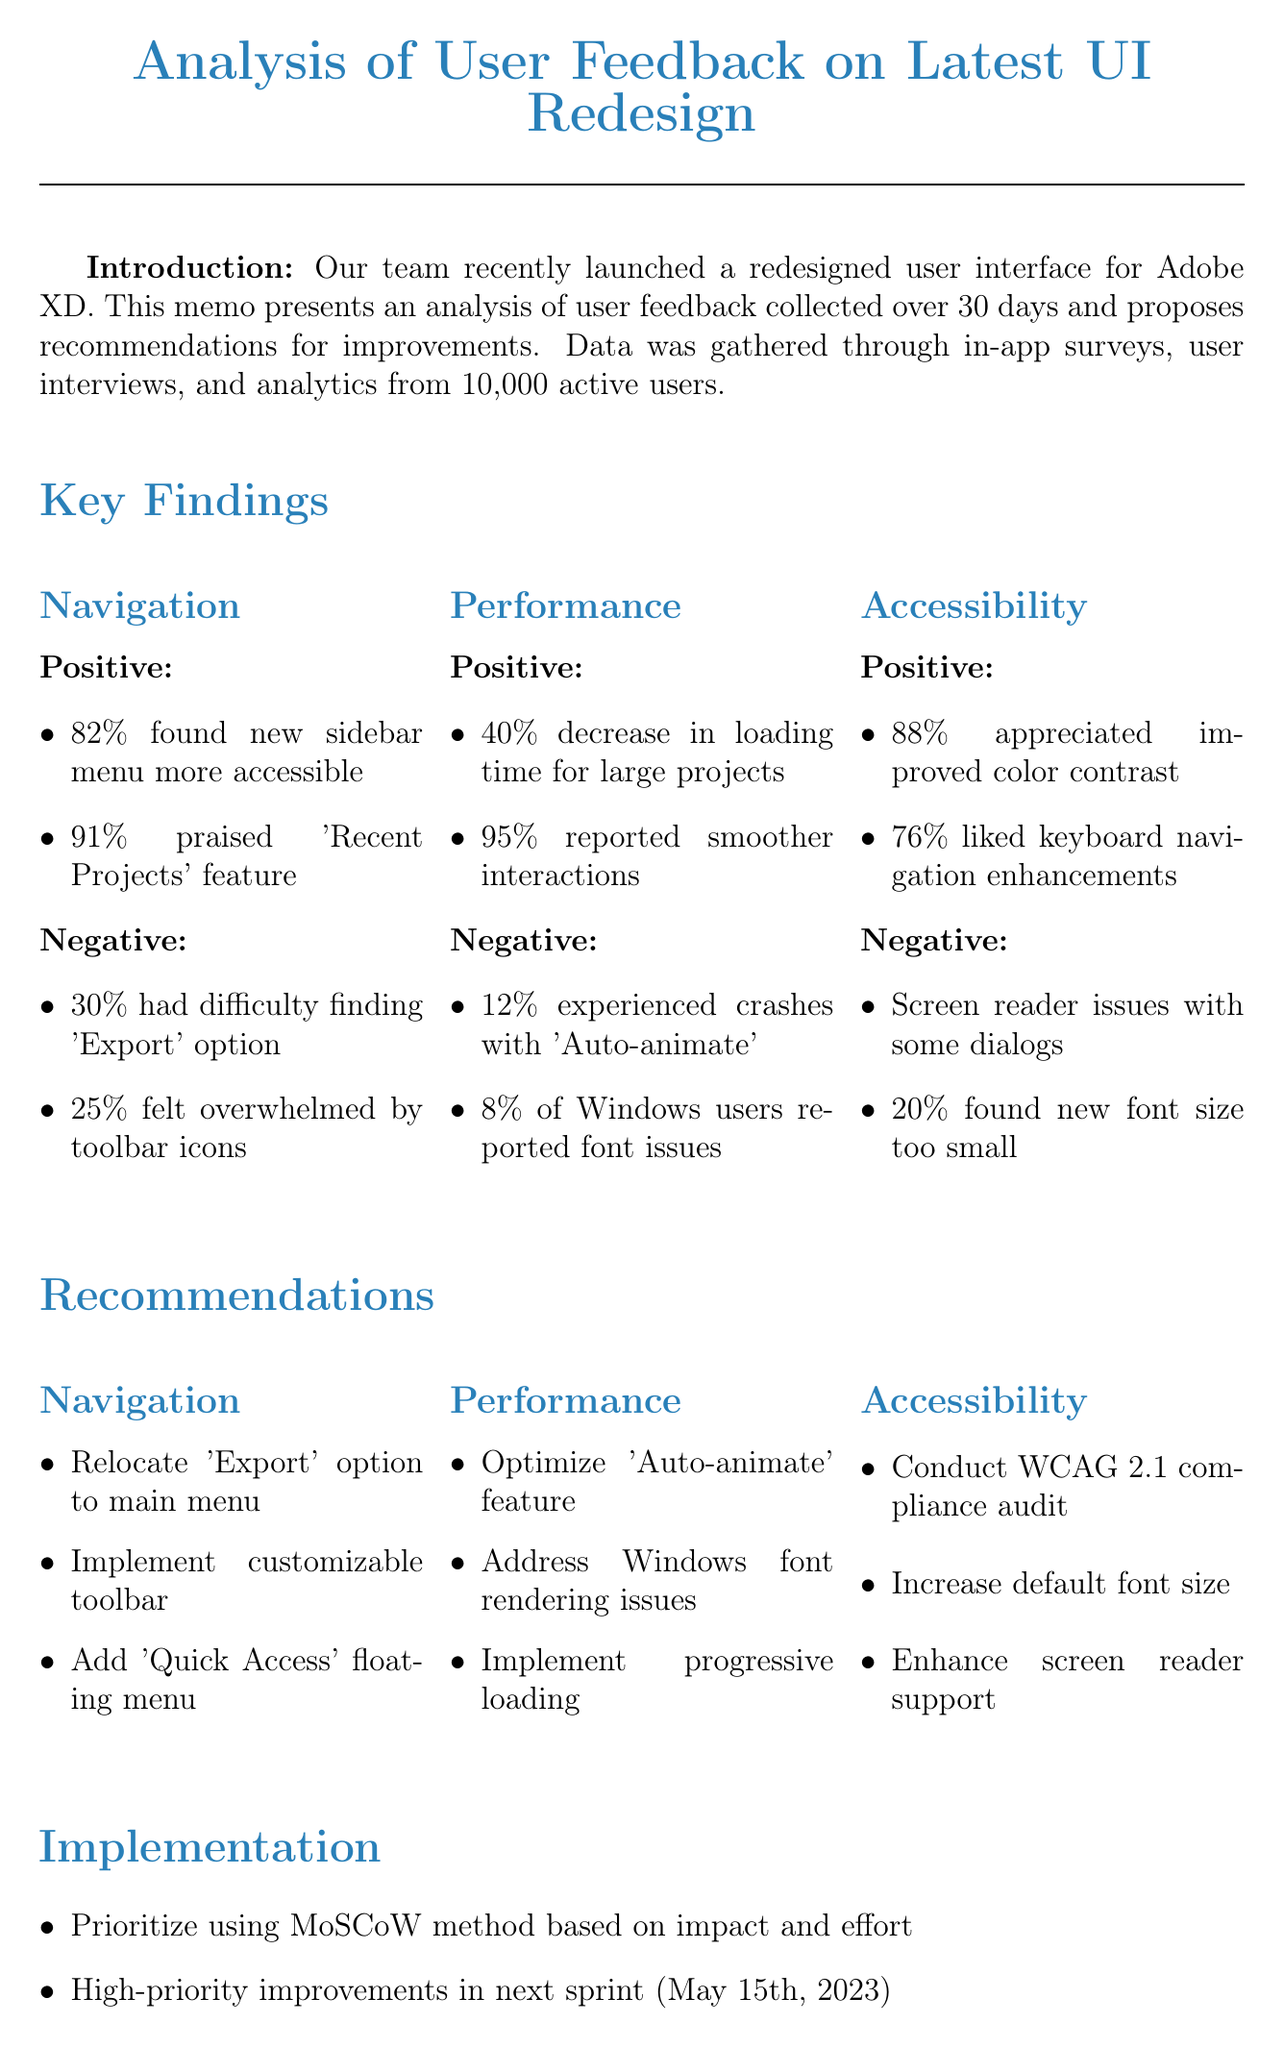What is the main product discussed in the memo? The memo focuses on the redesign of the user interface for the flagship product, Adobe XD.
Answer: Adobe XD How many active users provided feedback? User feedback was collected from a total of 10,000 active users over 30 days.
Answer: 10,000 What percentage of users reported smoother interactions? A high percentage of users, specifically 95%, reported smoother interactions when working on complex artboards.
Answer: 95% What recommendations are suggested for the Navigation category? Recommendations for Navigation include relocating the 'Export' option and introducing a customizable toolbar.
Answer: Relocate 'Export' option; customizable toolbar What date will high-priority improvements be included in the next sprint? The next sprint for implementing high-priority improvements is scheduled to start on May 15th, 2023.
Answer: May 15th, 2023 What issue was reported by 20% of users related to Accessibility? 20% of users found the new font size too small in certain areas, indicating a concern in accessibility.
Answer: New font size too small What method will be used to prioritize recommendations? The MoSCoW method will be employed to prioritize recommendations based on impact and effort.
Answer: MoSCoW method Which feature had a 40% decrease in loading time? The loading time for large projects experienced a decrease of 40% following the UI redesign.
Answer: Large projects 